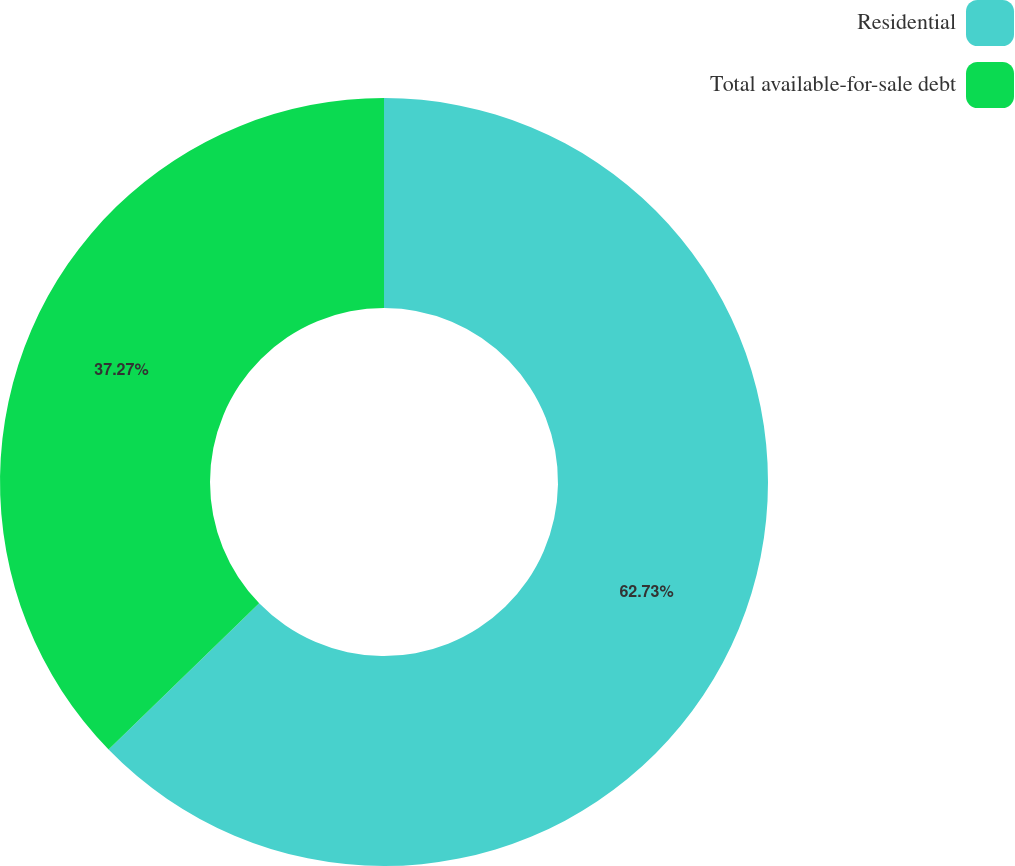Convert chart. <chart><loc_0><loc_0><loc_500><loc_500><pie_chart><fcel>Residential<fcel>Total available-for-sale debt<nl><fcel>62.73%<fcel>37.27%<nl></chart> 